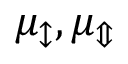<formula> <loc_0><loc_0><loc_500><loc_500>\mu _ { \updownarrow } , \mu _ { \Updownarrow }</formula> 